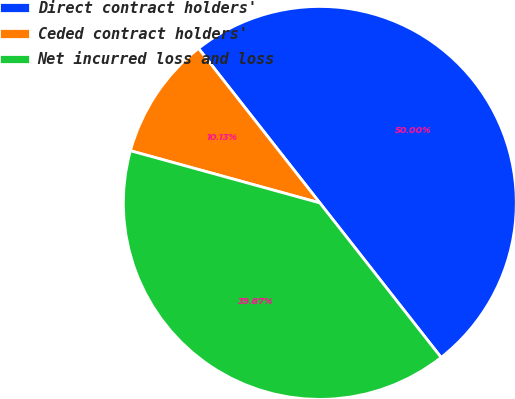Convert chart to OTSL. <chart><loc_0><loc_0><loc_500><loc_500><pie_chart><fcel>Direct contract holders'<fcel>Ceded contract holders'<fcel>Net incurred loss and loss<nl><fcel>50.0%<fcel>10.13%<fcel>39.87%<nl></chart> 